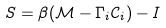<formula> <loc_0><loc_0><loc_500><loc_500>S = \beta ( \mathcal { M } - \Gamma _ { i } \mathcal { C } _ { i } ) - I</formula> 